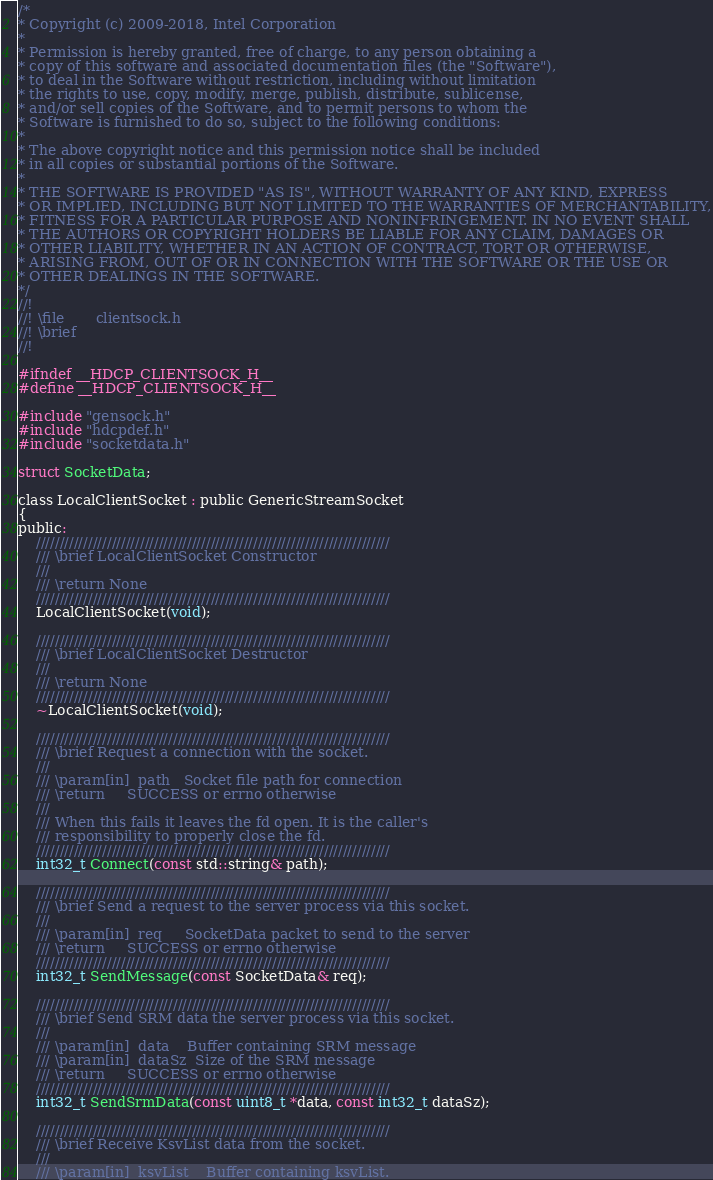Convert code to text. <code><loc_0><loc_0><loc_500><loc_500><_C_>/*
* Copyright (c) 2009-2018, Intel Corporation
*
* Permission is hereby granted, free of charge, to any person obtaining a
* copy of this software and associated documentation files (the "Software"),
* to deal in the Software without restriction, including without limitation
* the rights to use, copy, modify, merge, publish, distribute, sublicense,
* and/or sell copies of the Software, and to permit persons to whom the
* Software is furnished to do so, subject to the following conditions:
*
* The above copyright notice and this permission notice shall be included
* in all copies or substantial portions of the Software.
*
* THE SOFTWARE IS PROVIDED "AS IS", WITHOUT WARRANTY OF ANY KIND, EXPRESS
* OR IMPLIED, INCLUDING BUT NOT LIMITED TO THE WARRANTIES OF MERCHANTABILITY,
* FITNESS FOR A PARTICULAR PURPOSE AND NONINFRINGEMENT. IN NO EVENT SHALL
* THE AUTHORS OR COPYRIGHT HOLDERS BE LIABLE FOR ANY CLAIM, DAMAGES OR
* OTHER LIABILITY, WHETHER IN AN ACTION OF CONTRACT, TORT OR OTHERWISE,
* ARISING FROM, OUT OF OR IN CONNECTION WITH THE SOFTWARE OR THE USE OR
* OTHER DEALINGS IN THE SOFTWARE.
*/
//!
//! \file       clientsock.h
//! \brief
//!

#ifndef __HDCP_CLIENTSOCK_H__
#define __HDCP_CLIENTSOCK_H__

#include "gensock.h"
#include "hdcpdef.h"
#include "socketdata.h"

struct SocketData;

class LocalClientSocket : public GenericStreamSocket
{
public:
    ///////////////////////////////////////////////////////////////////////////
    /// \brief LocalClientSocket Constructor
    ///
    /// \return None
    ///////////////////////////////////////////////////////////////////////////
    LocalClientSocket(void);

    ///////////////////////////////////////////////////////////////////////////
    /// \brief LocalClientSocket Destructor
    ///
    /// \return None
    ///////////////////////////////////////////////////////////////////////////
    ~LocalClientSocket(void);

    ///////////////////////////////////////////////////////////////////////////
    /// \brief Request a connection with the socket.
    ///
    /// \param[in]  path   Socket file path for connection
    /// \return     SUCCESS or errno otherwise
    ///
    /// When this fails it leaves the fd open. It is the caller's
    /// responsibility to properly close the fd.
    ///////////////////////////////////////////////////////////////////////////
    int32_t Connect(const std::string& path);

    ///////////////////////////////////////////////////////////////////////////
    /// \brief Send a request to the server process via this socket.
    ///
    /// \param[in]  req     SocketData packet to send to the server
    /// \return     SUCCESS or errno otherwise
    ///////////////////////////////////////////////////////////////////////////
    int32_t SendMessage(const SocketData& req);

    ///////////////////////////////////////////////////////////////////////////
    /// \brief Send SRM data the server process via this socket.
    ///
    /// \param[in]  data    Buffer containing SRM message
    /// \param[in]  dataSz  Size of the SRM message
    /// \return     SUCCESS or errno otherwise
    ///////////////////////////////////////////////////////////////////////////
    int32_t SendSrmData(const uint8_t *data, const int32_t dataSz);

    ///////////////////////////////////////////////////////////////////////////
    /// \brief Receive KsvList data from the socket.
    ///
    /// \param[in]  ksvList    Buffer containing ksvList.</code> 